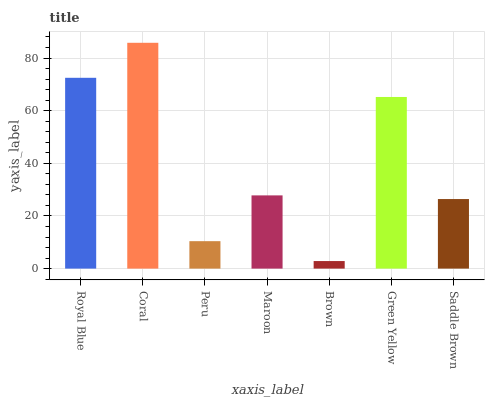Is Brown the minimum?
Answer yes or no. Yes. Is Coral the maximum?
Answer yes or no. Yes. Is Peru the minimum?
Answer yes or no. No. Is Peru the maximum?
Answer yes or no. No. Is Coral greater than Peru?
Answer yes or no. Yes. Is Peru less than Coral?
Answer yes or no. Yes. Is Peru greater than Coral?
Answer yes or no. No. Is Coral less than Peru?
Answer yes or no. No. Is Maroon the high median?
Answer yes or no. Yes. Is Maroon the low median?
Answer yes or no. Yes. Is Peru the high median?
Answer yes or no. No. Is Brown the low median?
Answer yes or no. No. 